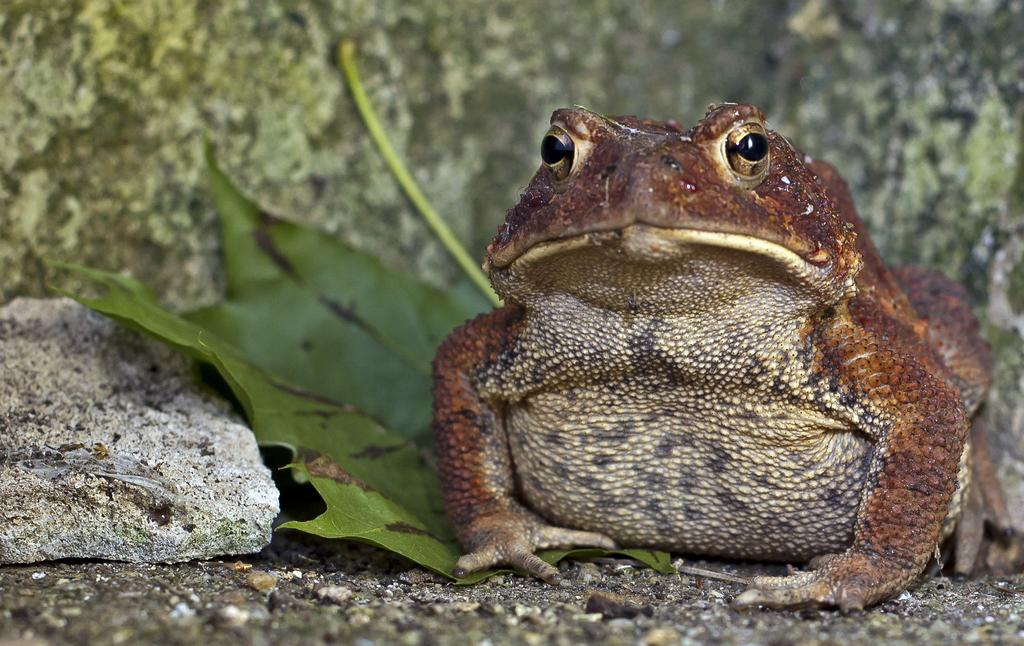What animal can be seen in the picture? There is a frog in the picture. What is the frog standing near? The frog is standing near leaves and a stone. What is visible at the top of the image? There is a wall visible at the top of the image. What type of fish can be seen swimming near the frog in the image? There are no fish present in the image; it features a frog standing near leaves and a stone. 